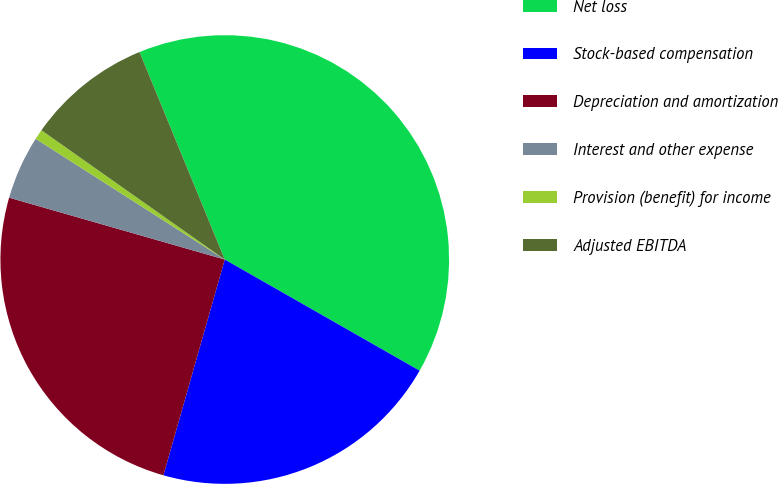Convert chart to OTSL. <chart><loc_0><loc_0><loc_500><loc_500><pie_chart><fcel>Net loss<fcel>Stock-based compensation<fcel>Depreciation and amortization<fcel>Interest and other expense<fcel>Provision (benefit) for income<fcel>Adjusted EBITDA<nl><fcel>39.46%<fcel>21.16%<fcel>25.04%<fcel>4.6%<fcel>0.73%<fcel>9.02%<nl></chart> 